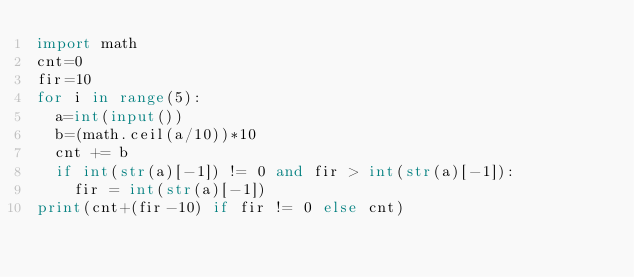Convert code to text. <code><loc_0><loc_0><loc_500><loc_500><_Python_>import math
cnt=0
fir=10
for i in range(5):
	a=int(input())
	b=(math.ceil(a/10))*10
	cnt += b
	if int(str(a)[-1]) != 0 and fir > int(str(a)[-1]):
		fir = int(str(a)[-1])
print(cnt+(fir-10) if fir != 0 else cnt)</code> 